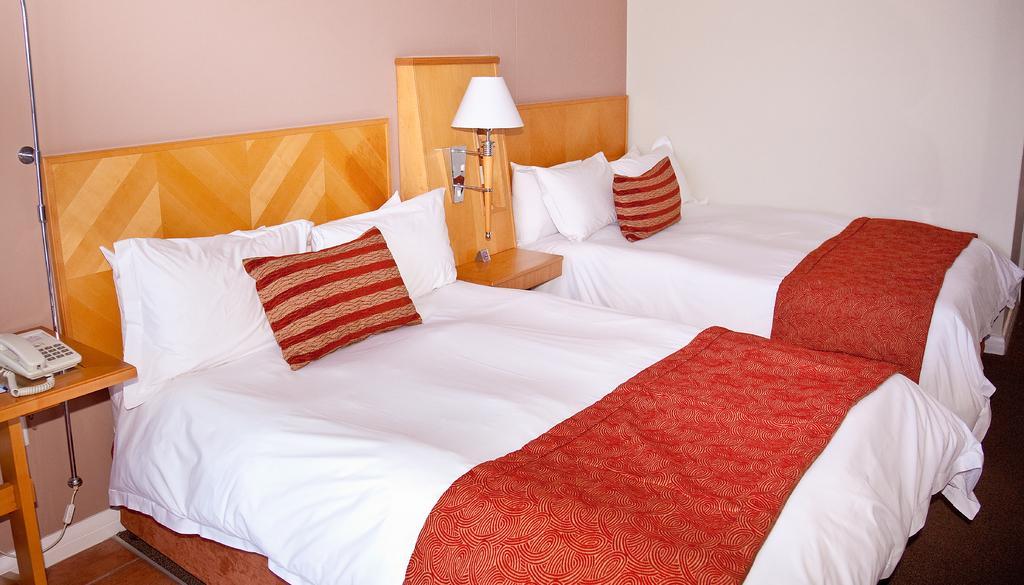Can you describe this image briefly? In this image I can see two beds. On the bed there are pillows. To the side of bed there is a telephone and the lamp. 